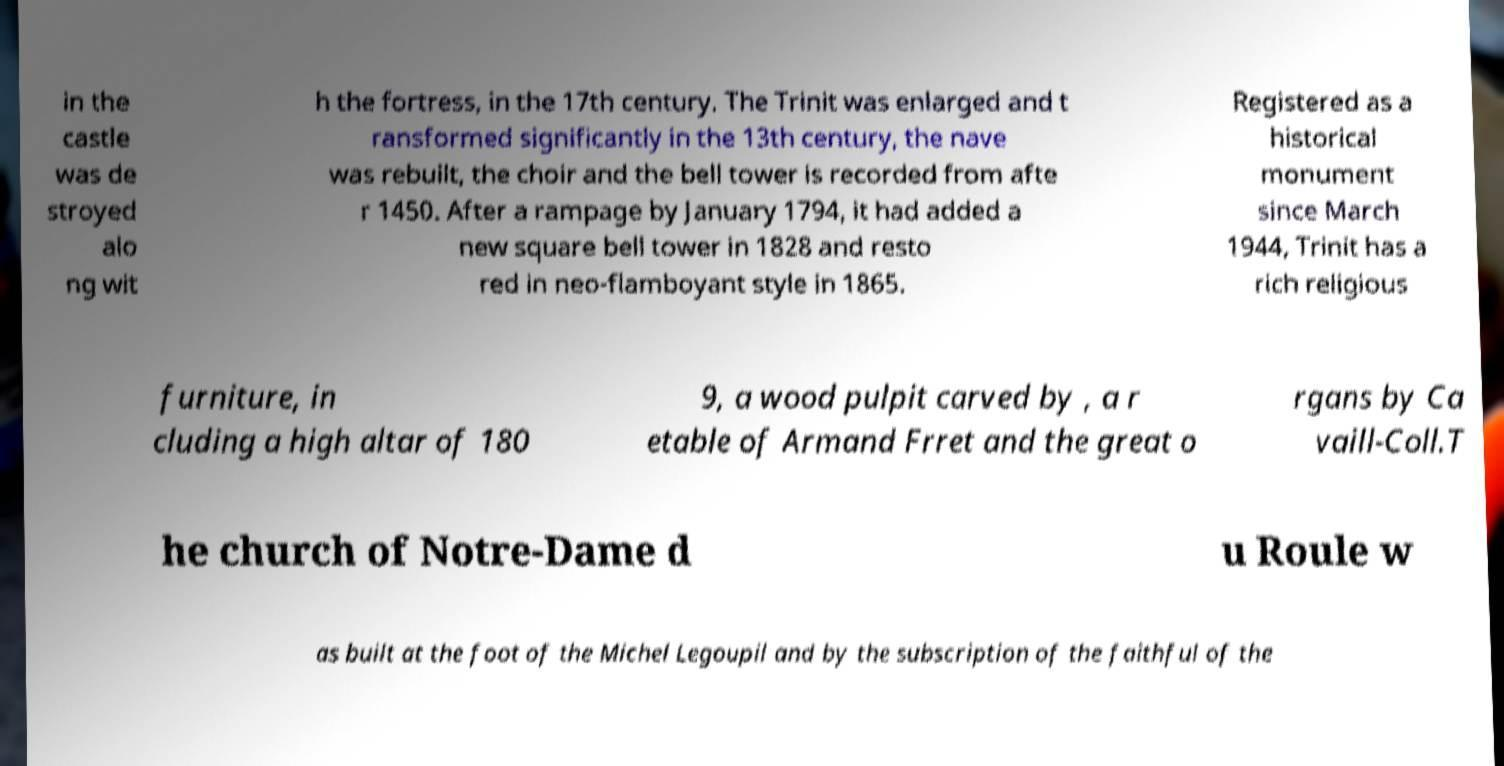What messages or text are displayed in this image? I need them in a readable, typed format. in the castle was de stroyed alo ng wit h the fortress, in the 17th century. The Trinit was enlarged and t ransformed significantly in the 13th century, the nave was rebuilt, the choir and the bell tower is recorded from afte r 1450. After a rampage by January 1794, it had added a new square bell tower in 1828 and resto red in neo-flamboyant style in 1865. Registered as a historical monument since March 1944, Trinit has a rich religious furniture, in cluding a high altar of 180 9, a wood pulpit carved by , a r etable of Armand Frret and the great o rgans by Ca vaill-Coll.T he church of Notre-Dame d u Roule w as built at the foot of the Michel Legoupil and by the subscription of the faithful of the 